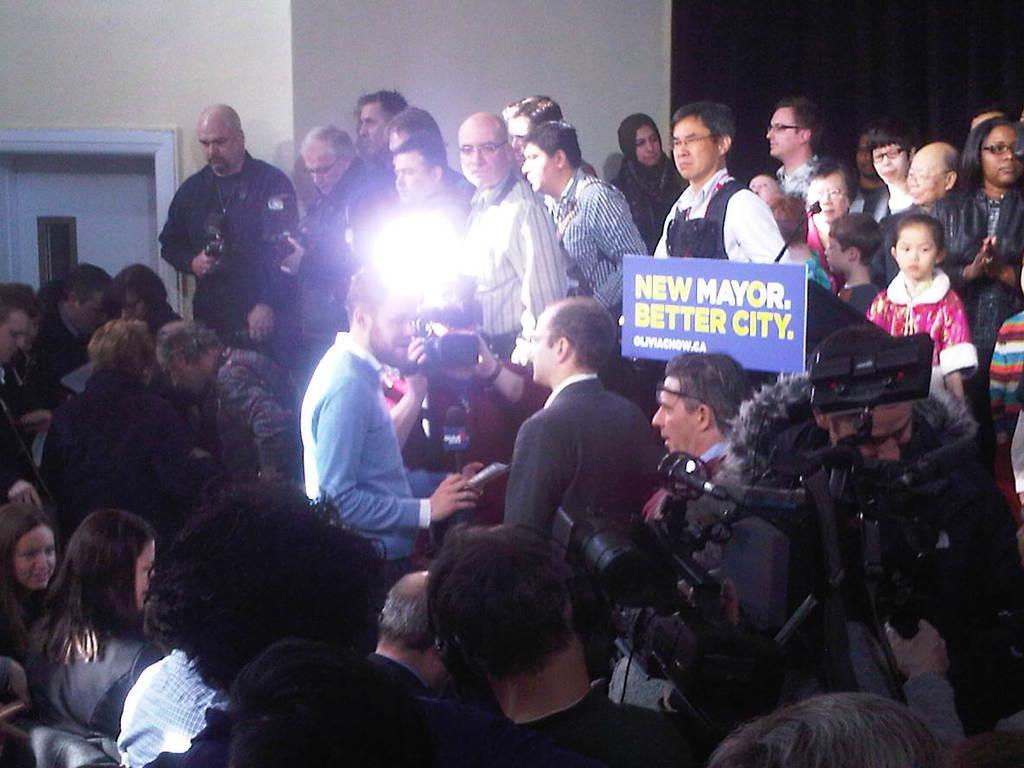How would you summarize this image in a sentence or two? In this image I see number of people in which few of them are holding cameras in their hands and I see a board over here on which there is something written and in the background I see the wall and I see the door over here and I see the black color curtain. 